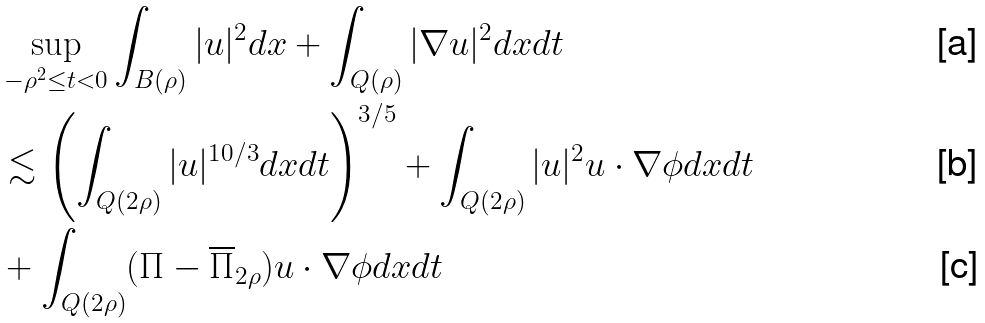Convert formula to latex. <formula><loc_0><loc_0><loc_500><loc_500>& \sup _ { - \rho ^ { 2 } \leq t < 0 } \int _ { B ( \rho ) } | u | ^ { 2 } d x + \int _ { Q ( \rho ) } | \nabla u | ^ { 2 } d x d t \\ & \lesssim \left ( \int _ { Q ( 2 \rho ) } | u | ^ { 1 0 / 3 } d x d t \right ) ^ { 3 / 5 } + \int _ { Q ( 2 \rho ) } | u | ^ { 2 } u \cdot \nabla \phi d x d t \\ & + \int _ { Q ( 2 \rho ) } ( \Pi - \overline { \Pi } _ { 2 \rho } ) u \cdot \nabla \phi d x d t</formula> 